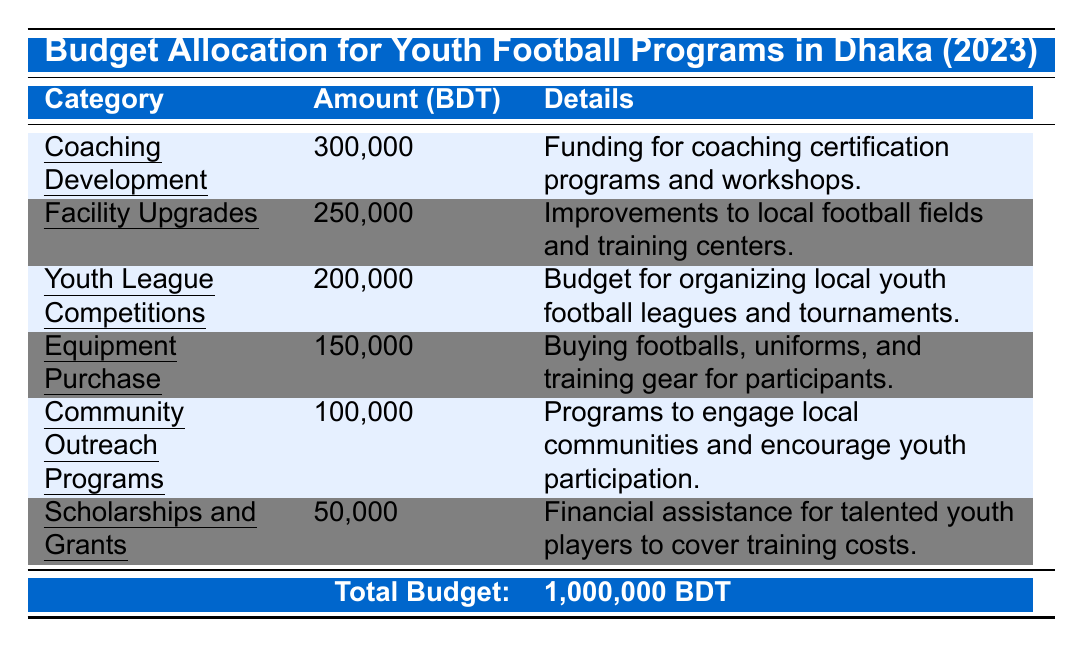What is the total budget allocated for youth football programs in Dhaka for 2023? The total budget is explicitly stated in the table under the total budget row. It shows that the total budget for 2023 is 1,000,000 BDT.
Answer: 1,000,000 BDT Which category received the highest budget allocation? By reviewing the amounts allocated to each category, Coaching Development has the highest allocation at 300,000 BDT compared to others.
Answer: Coaching Development What is the budget for Community Outreach Programs? The table lists Community Outreach Programs with a budget amount explicitly stated next to it as 100,000 BDT.
Answer: 100,000 BDT How much less is allocated to Scholarships and Grants than to Facility Upgrades? The amount allocated to Scholarships and Grants is 50,000 BDT while Facility Upgrades is 250,000 BDT. The difference is calculated as 250,000 - 50,000 = 200,000 BDT.
Answer: 200,000 BDT What is the total budget allocated for Equipment Purchase and Youth League Competitions combined? The budget for Equipment Purchase is 150,000 BDT, and for Youth League Competitions is 200,000 BDT. Adding these two gives 150,000 + 200,000 = 350,000 BDT.
Answer: 350,000 BDT Is the budget for Coaching Development more than the sum of Scholarships and Grants and Community Outreach Programs? The budget for Coaching Development is 300,000 BDT. The sum of Scholarships and Grants (50,000 BDT) and Community Outreach Programs (100,000 BDT) is 150,000 BDT (50,000 + 100,000). Since 300,000 > 150,000, it is true.
Answer: Yes How does the budget allocation for Equipment Purchase compare to that for Facility Upgrades? The budget for Equipment Purchase is 150,000 BDT and for Facility Upgrades is 250,000 BDT. Comparing these two, it shows that Facility Upgrades received 100,000 BDT more.
Answer: Facility Upgrades received more by 100,000 BDT What percentage of the total budget is allocated to Youth League Competitions? The budget for Youth League Competitions is 200,000 BDT. To find the percentage, calculate (200,000 / 1,000,000) * 100% = 20%.
Answer: 20% 